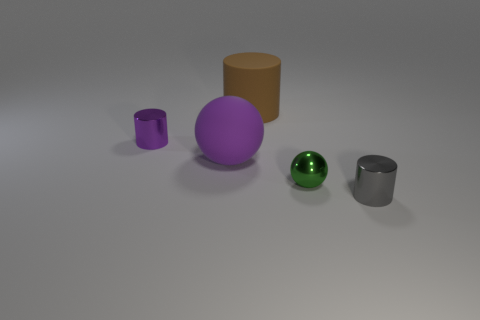Add 3 purple rubber balls. How many objects exist? 8 Subtract all purple cylinders. How many cylinders are left? 2 Subtract 1 cylinders. How many cylinders are left? 2 Subtract all gray cylinders. How many cylinders are left? 2 Subtract all spheres. How many objects are left? 3 Add 2 gray objects. How many gray objects are left? 3 Add 5 tiny blue metal objects. How many tiny blue metal objects exist? 5 Subtract 0 cyan spheres. How many objects are left? 5 Subtract all green spheres. Subtract all brown cylinders. How many spheres are left? 1 Subtract all yellow balls. How many yellow cylinders are left? 0 